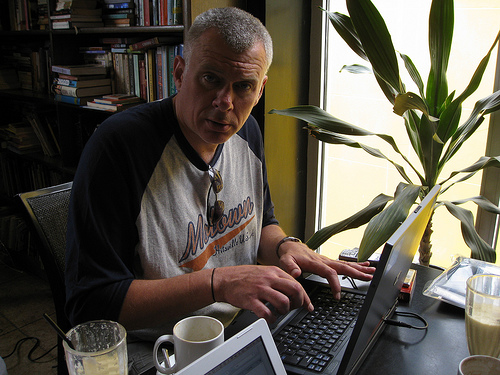<image>
Can you confirm if the chair is in the man? No. The chair is not contained within the man. These objects have a different spatial relationship. 